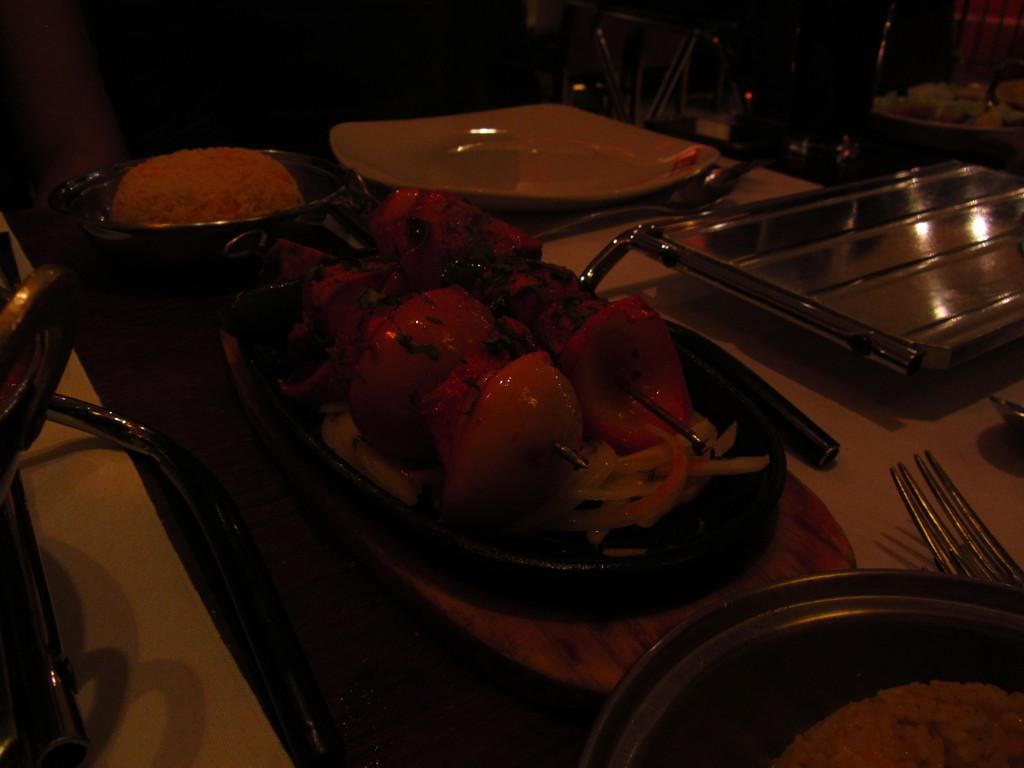What type of food items can be seen in the image? There are food items in bowls and on a plate in the image. Where are these food items located? All of these items are on a table. What other items can be seen on the table in the background of the image? There is a silver tray, a plate, a spoon, and a fork in the background of the image. What is the slope of the table in the image? There is no mention of a slope in the image, as the table appears to be flat. What position does the fork hold in the image? The position of the fork cannot be determined from the image, as it is not shown in use or interacting with any other objects. 